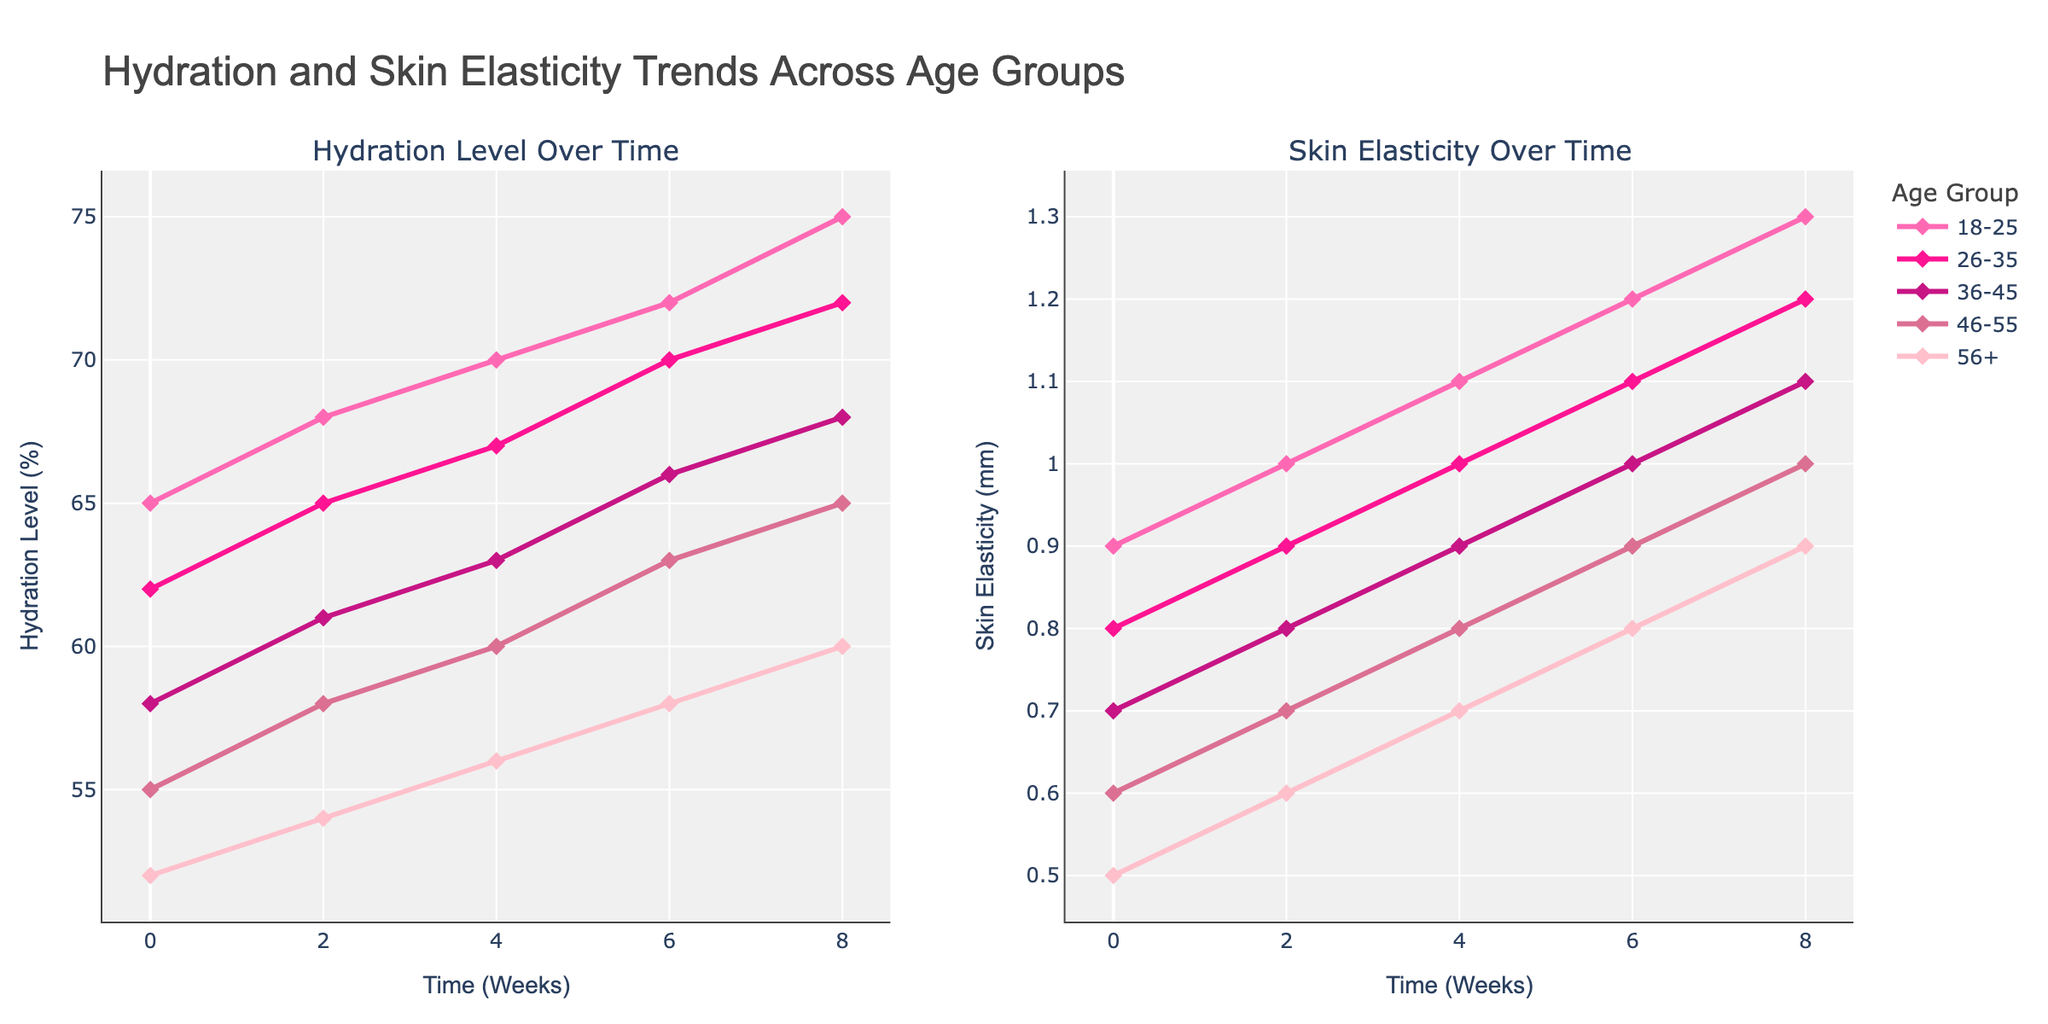What is the percentage increase in hydration level for the 18-25 age group from 0 to 8 weeks? First, find the hydration levels for the 18-25 age group at week 0 and week 8. They are 65% and 75%, respectively. The percentage increase is calculated by (75 - 65) / 65 * 100. So, the increase is (10 / 65) * 100 ≈ 15.38%.
Answer: 15.38% Which age group shows the highest increase in skin elasticity from 0 to 8 weeks? Check the skin elasticity values at 0 and 8 weeks for each age group. The values for the 18-25, 26-35, 36-45, 46-55, and 56+ age groups are (0.9 to 1.3), (0.8 to 1.2), (0.7 to 1.1), (0.6 to 1.0), and (0.5 to 0.9) respectively. The differences are 0.4, 0.4, 0.4, 0.4, and 0.4 mm, respectively. Comparatively, all age groups show the same increase in skin elasticity of 0.4 mm.
Answer: All age groups show the same increase Which age group has the lowest hydration level at 0 weeks? Examine the values of hydration levels at 0 weeks for each age group. They are 65%, 62%, 58%, 55%, and 52% for the 18-25, 26-35, 36-45, 46-55, and 56+ age groups, respectively. The lowest value is 52% in the 56+ age group.
Answer: 56+ How does the skin elasticity of the 36-45 age group at 4 weeks compare to the 46-55 age group at 6 weeks? The skin elasticity of the 36-45 age group at 4 weeks is 0.9 mm and for the 46-55 age group at 6 weeks it is also 0.9 mm. Since they are equal, the comparison is 0.9 mm = 0.9 mm.
Answer: Equal Which age group shows the most gradual increase in hydration level over time? Identify the trends for hydration levels over time for each age group and determine the pattern of increase. The 18-25 age group increases from 65% to 75%, 26-35 from 62% to 72%, 36-45 from 58% to 68%, 46-55 from 55% to 65%, and 56+ from 52% to 60%. All groups show a linear increase, so none is more gradual than the others.
Answer: All are equal If the skin elasticity is directly proportional to hydration level, does the data support this hypothesis? To check if skin elasticity is directly proportional to hydration level, examine the consistency of increase between these two metrics for each age group. For example, the 18-25 age group shows an increase from 65% to 75% in hydration and 0.9 to 1.3 mm in elasticity. Similar proportional increases are observed for all other age groups. Thus, the data supports that skin elasticity is directly proportional to hydration level for all age groups.
Answer: Yes, supports Which age group shows the most significant change in skin elasticity within the first 2 weeks? Evaluate the change in skin elasticity from week 0 to week 2 for each age group. The changes are: 18-25 (0.9 to 1.0), 26-35 (0.8 to 0.9), 36-45 (0.7 to 0.8), 46-55 (0.6 to 0.7), and 56+ (0.5 to 0.6). All age groups show a 0.1 mm increase in skin elasticity in the first 2 weeks.
Answer: All groups equally At what time point do the hydration levels of the 36-45 age group align with the initial level of the 26-35 age group? The initial hydration level of the 26-35 age group is 62%. Analyze the hydration levels over time for the 36-45 age group: 58% (0 weeks), 61% (2 weeks), 63% (4 weeks), 66% (6 weeks), and 68% (8 weeks). The hydration level of 36-45 aligns with 62% at around 2 weeks.
Answer: 2 weeks 